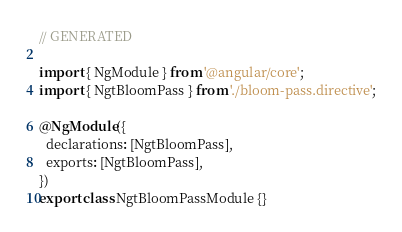<code> <loc_0><loc_0><loc_500><loc_500><_TypeScript_>// GENERATED

import { NgModule } from '@angular/core';
import { NgtBloomPass } from './bloom-pass.directive';

@NgModule({
  declarations: [NgtBloomPass],
  exports: [NgtBloomPass],
})
export class NgtBloomPassModule {}
</code> 